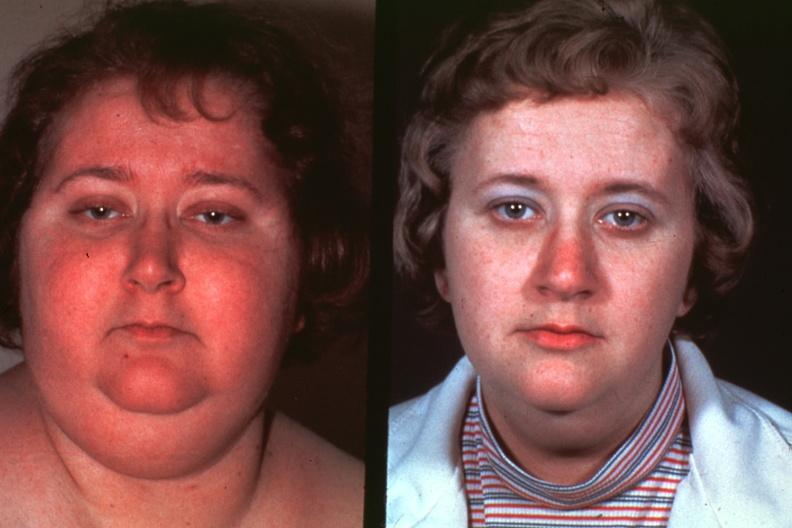what is present?
Answer the question using a single word or phrase. Face 